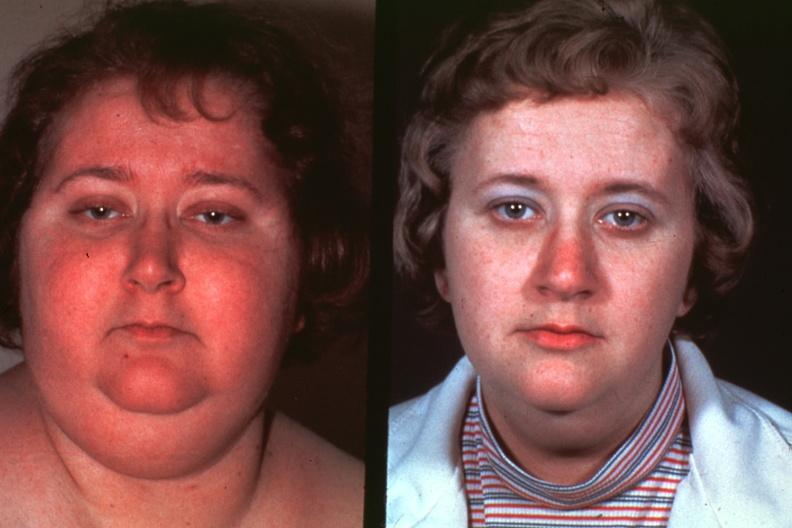what is present?
Answer the question using a single word or phrase. Face 